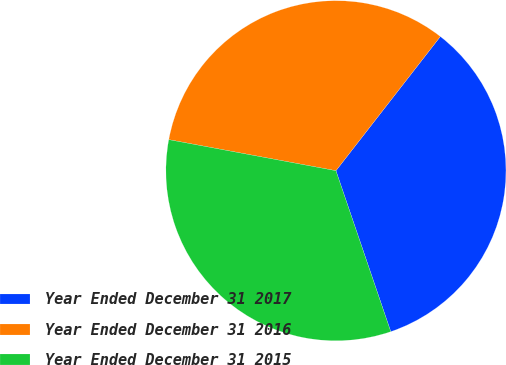Convert chart. <chart><loc_0><loc_0><loc_500><loc_500><pie_chart><fcel>Year Ended December 31 2017<fcel>Year Ended December 31 2016<fcel>Year Ended December 31 2015<nl><fcel>34.25%<fcel>32.6%<fcel>33.15%<nl></chart> 